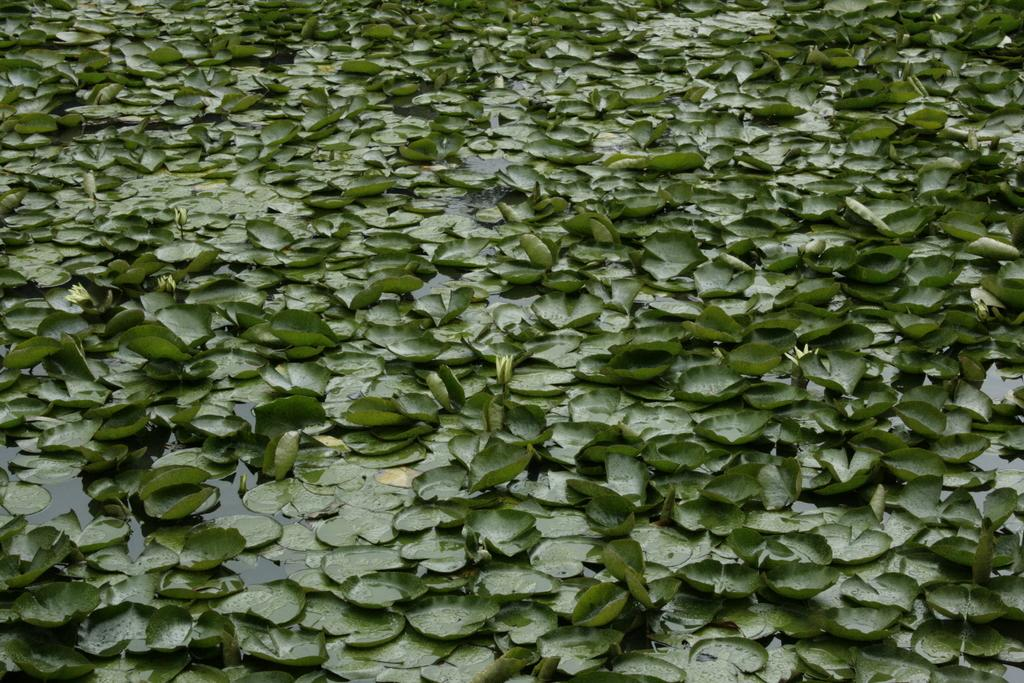What type of vegetation is visible in the image? There are green leaves visible in the image. Where are the green leaves located? The green leaves are on the water. What type of cup is being used to hold the edge of the green leaves in the image? There is no cup present in the image, and the green leaves are not being held by any object. 